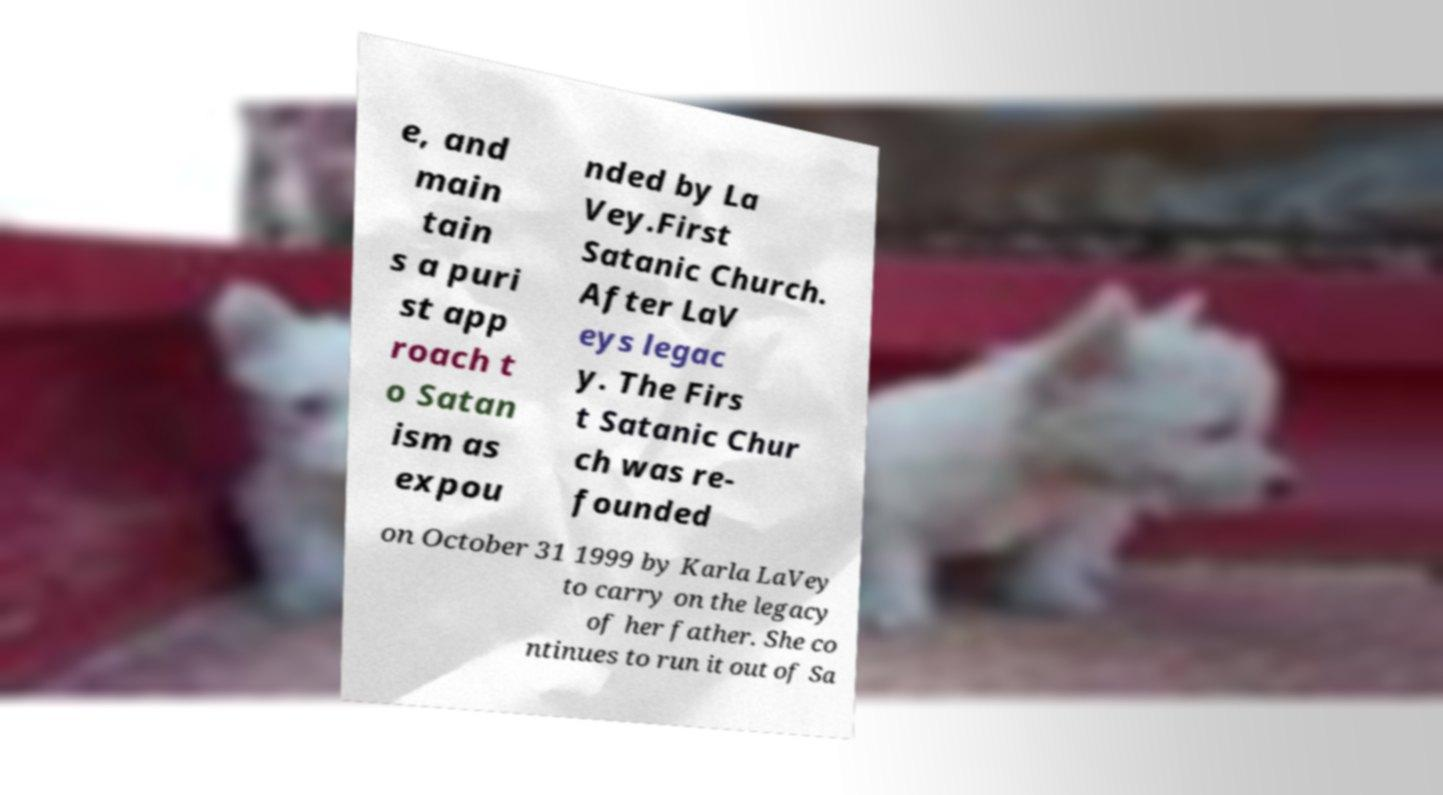Please identify and transcribe the text found in this image. e, and main tain s a puri st app roach t o Satan ism as expou nded by La Vey.First Satanic Church. After LaV eys legac y. The Firs t Satanic Chur ch was re- founded on October 31 1999 by Karla LaVey to carry on the legacy of her father. She co ntinues to run it out of Sa 